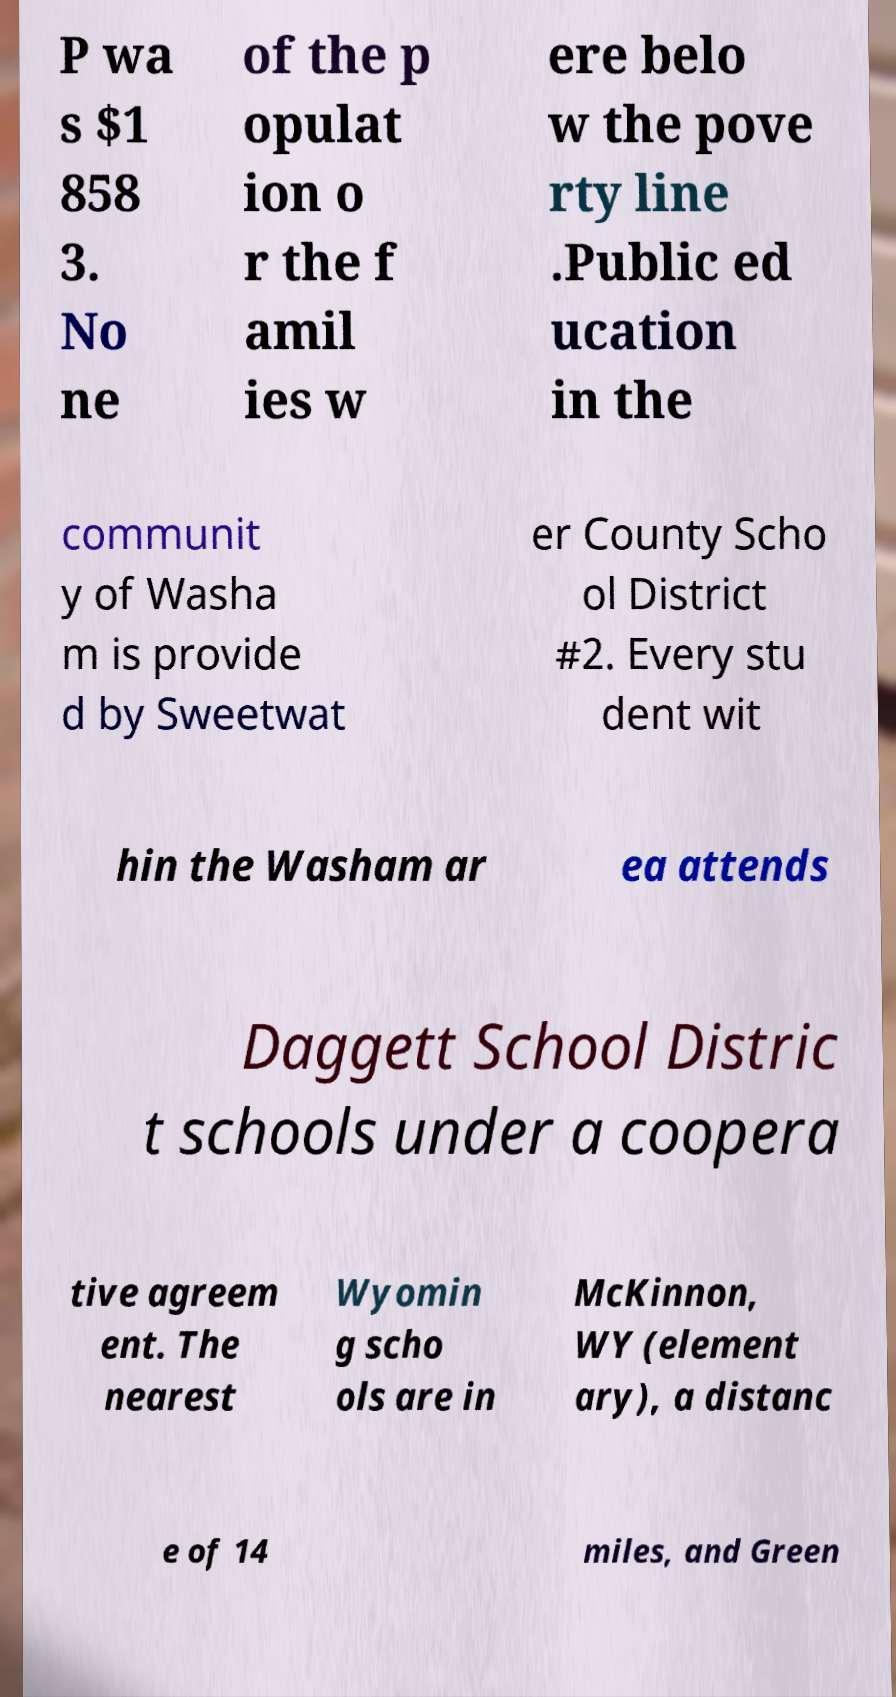Could you extract and type out the text from this image? P wa s $1 858 3. No ne of the p opulat ion o r the f amil ies w ere belo w the pove rty line .Public ed ucation in the communit y of Washa m is provide d by Sweetwat er County Scho ol District #2. Every stu dent wit hin the Washam ar ea attends Daggett School Distric t schools under a coopera tive agreem ent. The nearest Wyomin g scho ols are in McKinnon, WY (element ary), a distanc e of 14 miles, and Green 